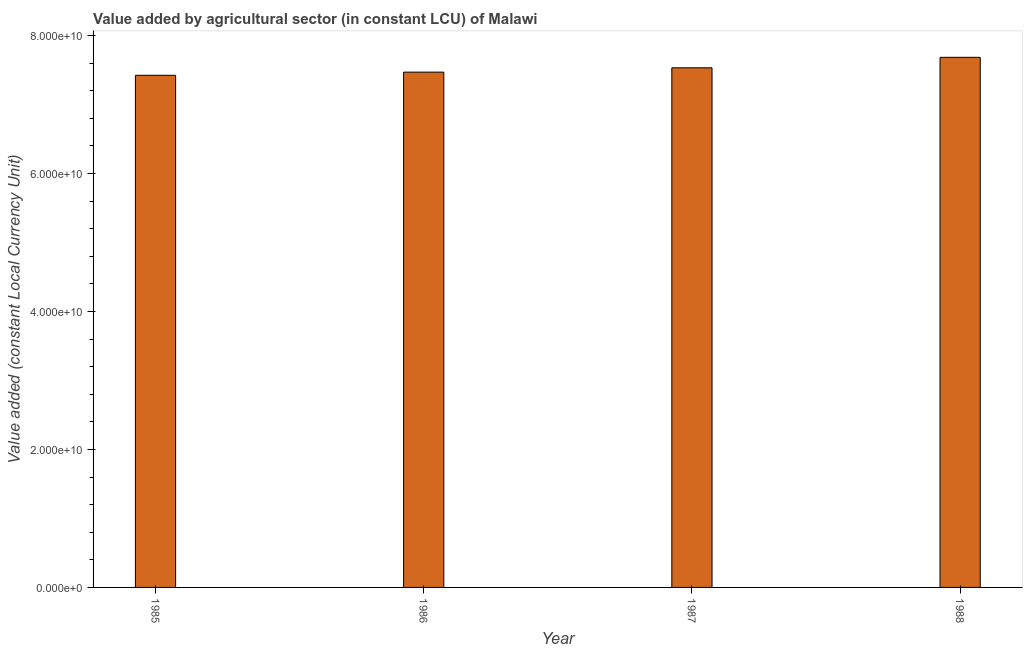Does the graph contain any zero values?
Make the answer very short. No. What is the title of the graph?
Keep it short and to the point. Value added by agricultural sector (in constant LCU) of Malawi. What is the label or title of the Y-axis?
Provide a succinct answer. Value added (constant Local Currency Unit). What is the value added by agriculture sector in 1987?
Make the answer very short. 7.53e+1. Across all years, what is the maximum value added by agriculture sector?
Provide a succinct answer. 7.68e+1. Across all years, what is the minimum value added by agriculture sector?
Your answer should be very brief. 7.42e+1. In which year was the value added by agriculture sector maximum?
Your response must be concise. 1988. In which year was the value added by agriculture sector minimum?
Your response must be concise. 1985. What is the sum of the value added by agriculture sector?
Your response must be concise. 3.01e+11. What is the difference between the value added by agriculture sector in 1985 and 1987?
Offer a terse response. -1.08e+09. What is the average value added by agriculture sector per year?
Keep it short and to the point. 7.53e+1. What is the median value added by agriculture sector?
Your answer should be very brief. 7.50e+1. In how many years, is the value added by agriculture sector greater than 68000000000 LCU?
Make the answer very short. 4. Do a majority of the years between 1986 and 1985 (inclusive) have value added by agriculture sector greater than 16000000000 LCU?
Give a very brief answer. No. What is the ratio of the value added by agriculture sector in 1986 to that in 1987?
Provide a succinct answer. 0.99. Is the difference between the value added by agriculture sector in 1985 and 1986 greater than the difference between any two years?
Your answer should be compact. No. What is the difference between the highest and the second highest value added by agriculture sector?
Your response must be concise. 1.52e+09. Is the sum of the value added by agriculture sector in 1986 and 1988 greater than the maximum value added by agriculture sector across all years?
Ensure brevity in your answer.  Yes. What is the difference between the highest and the lowest value added by agriculture sector?
Keep it short and to the point. 2.60e+09. In how many years, is the value added by agriculture sector greater than the average value added by agriculture sector taken over all years?
Your response must be concise. 2. Are all the bars in the graph horizontal?
Give a very brief answer. No. What is the difference between two consecutive major ticks on the Y-axis?
Provide a short and direct response. 2.00e+1. Are the values on the major ticks of Y-axis written in scientific E-notation?
Ensure brevity in your answer.  Yes. What is the Value added (constant Local Currency Unit) of 1985?
Give a very brief answer. 7.42e+1. What is the Value added (constant Local Currency Unit) in 1986?
Provide a succinct answer. 7.47e+1. What is the Value added (constant Local Currency Unit) in 1987?
Make the answer very short. 7.53e+1. What is the Value added (constant Local Currency Unit) in 1988?
Keep it short and to the point. 7.68e+1. What is the difference between the Value added (constant Local Currency Unit) in 1985 and 1986?
Ensure brevity in your answer.  -4.58e+08. What is the difference between the Value added (constant Local Currency Unit) in 1985 and 1987?
Give a very brief answer. -1.08e+09. What is the difference between the Value added (constant Local Currency Unit) in 1985 and 1988?
Provide a short and direct response. -2.60e+09. What is the difference between the Value added (constant Local Currency Unit) in 1986 and 1987?
Provide a succinct answer. -6.27e+08. What is the difference between the Value added (constant Local Currency Unit) in 1986 and 1988?
Provide a short and direct response. -2.15e+09. What is the difference between the Value added (constant Local Currency Unit) in 1987 and 1988?
Keep it short and to the point. -1.52e+09. What is the ratio of the Value added (constant Local Currency Unit) in 1986 to that in 1987?
Provide a short and direct response. 0.99. What is the ratio of the Value added (constant Local Currency Unit) in 1986 to that in 1988?
Your answer should be compact. 0.97. What is the ratio of the Value added (constant Local Currency Unit) in 1987 to that in 1988?
Your answer should be very brief. 0.98. 